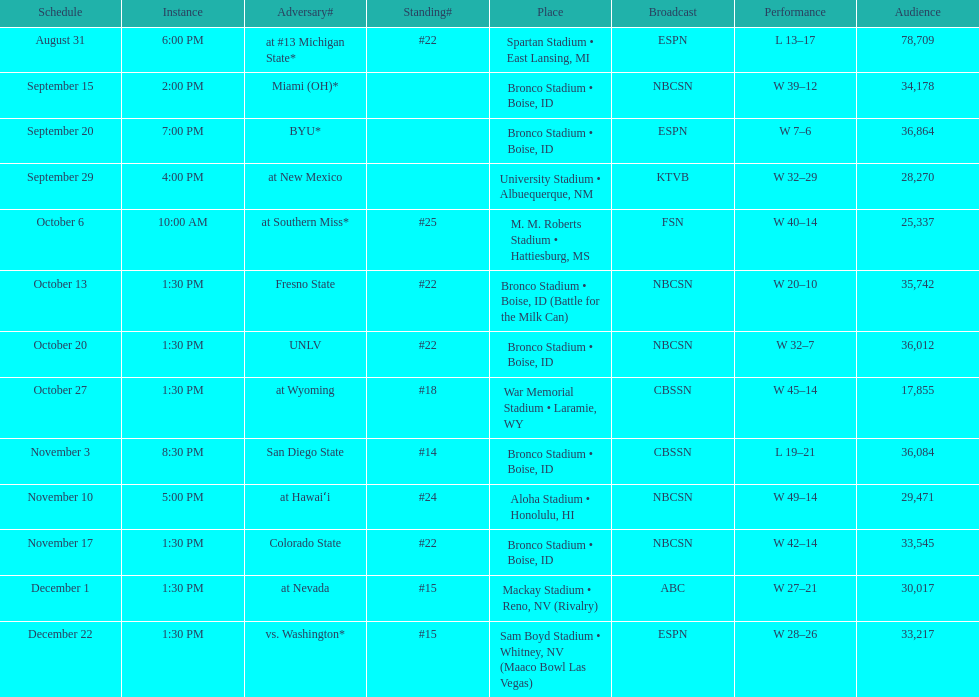What was the most consecutive wins for the team shown in the season? 7. 